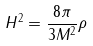<formula> <loc_0><loc_0><loc_500><loc_500>H ^ { 2 } = \frac { 8 \pi } { 3 M ^ { 2 } } \rho</formula> 